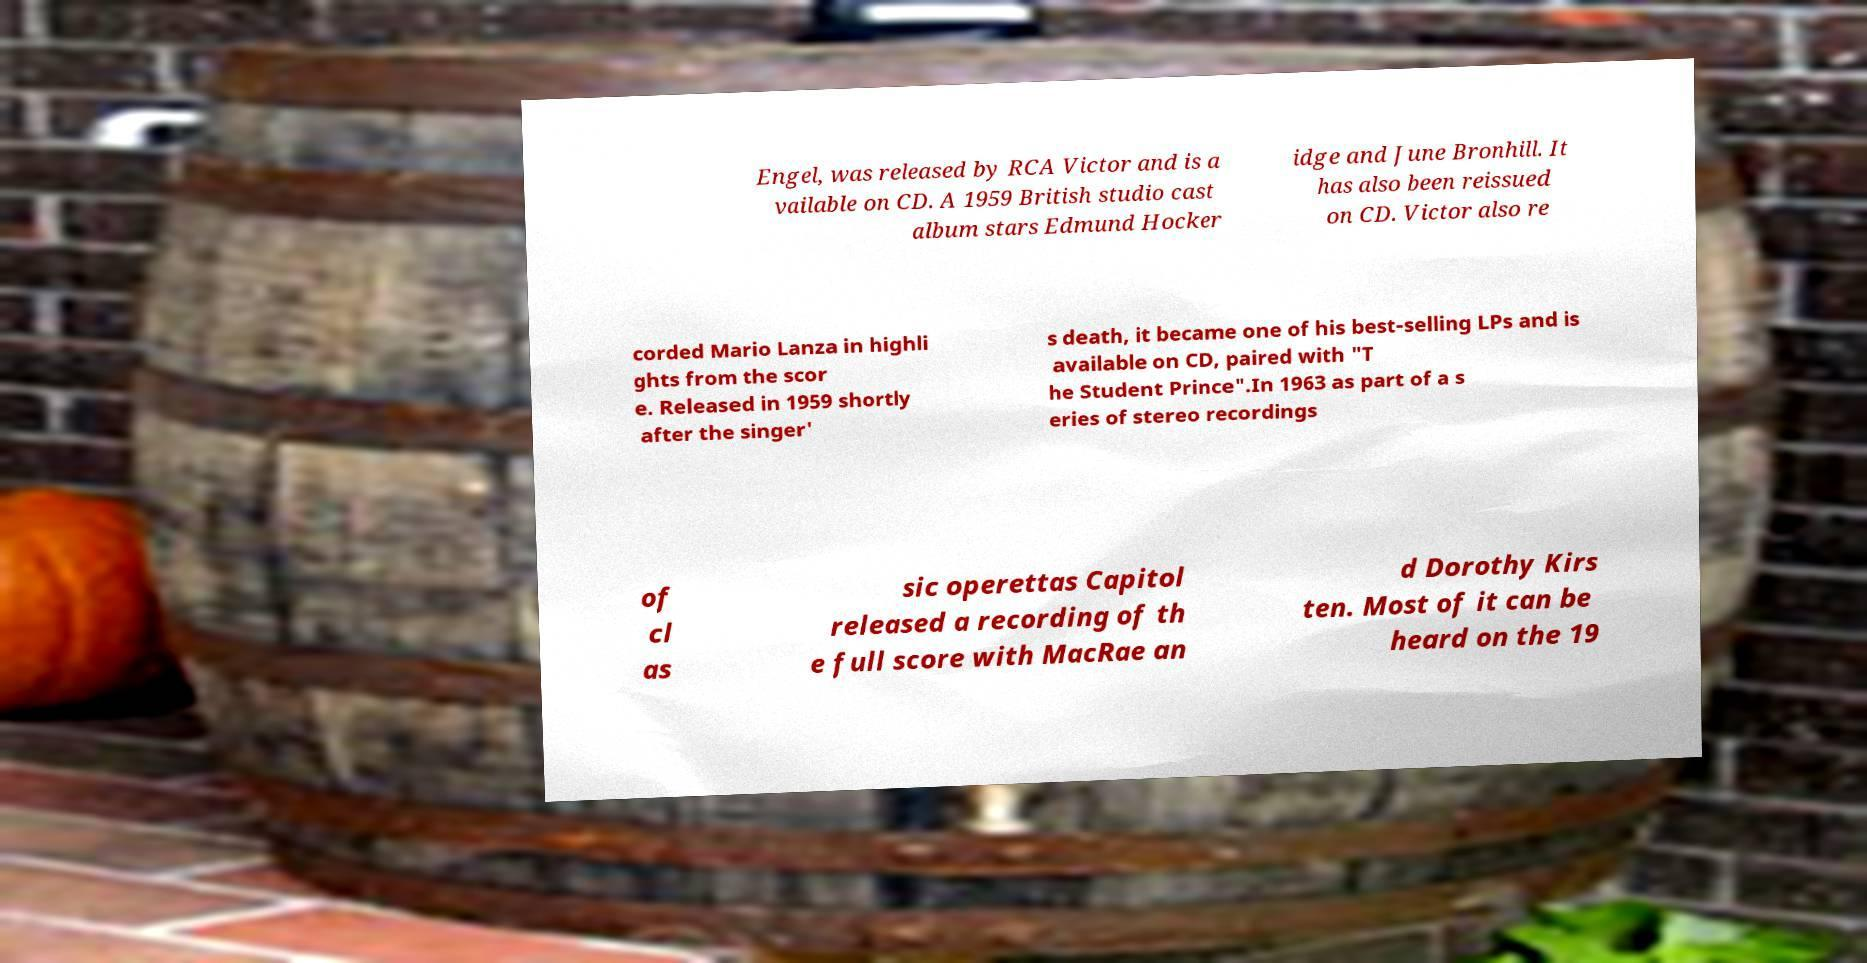For documentation purposes, I need the text within this image transcribed. Could you provide that? Engel, was released by RCA Victor and is a vailable on CD. A 1959 British studio cast album stars Edmund Hocker idge and June Bronhill. It has also been reissued on CD. Victor also re corded Mario Lanza in highli ghts from the scor e. Released in 1959 shortly after the singer' s death, it became one of his best-selling LPs and is available on CD, paired with "T he Student Prince".In 1963 as part of a s eries of stereo recordings of cl as sic operettas Capitol released a recording of th e full score with MacRae an d Dorothy Kirs ten. Most of it can be heard on the 19 